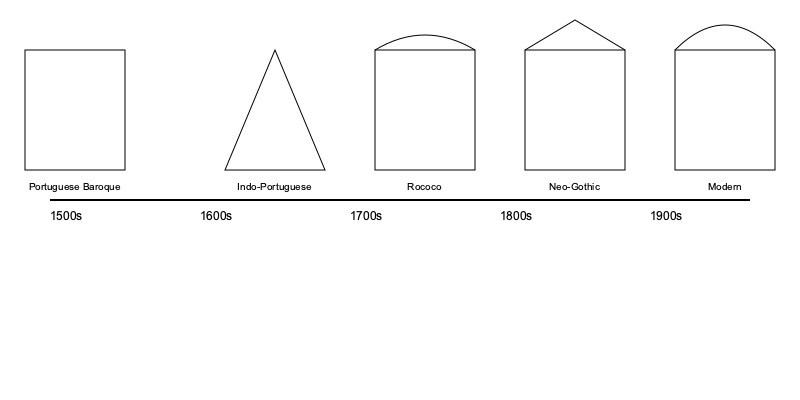Based on the timeline of architectural styles in Indian Catholic churches, which style emerged during the 1700s and is characterized by ornate decorations and curved forms? To answer this question, let's analyze the timeline of architectural styles presented in the graphic:

1. 1500s: Portuguese Baroque style is shown, characterized by rectangular forms.
2. 1600s: Indo-Portuguese style is depicted, featuring a triangular shape, likely representing a fusion of Indian and Portuguese elements.
3. 1700s: The style shown here is Rococo, identifiable by its rectangular base with a curved top, indicating ornate decorations and curved forms.
4. 1800s: Neo-Gothic style is represented, with a rectangular base and pointed arch, typical of Gothic revival architecture.
5. 1900s: Modern style is illustrated, showing a rectangular base with a pronounced curved roof, representing contemporary architectural trends.

The question specifically asks about the style that emerged in the 1700s and is characterized by ornate decorations and curved forms. This description perfectly matches the Rococo style, which is known for its elaborate ornamentation and emphasis on curves and asymmetry.
Answer: Rococo 